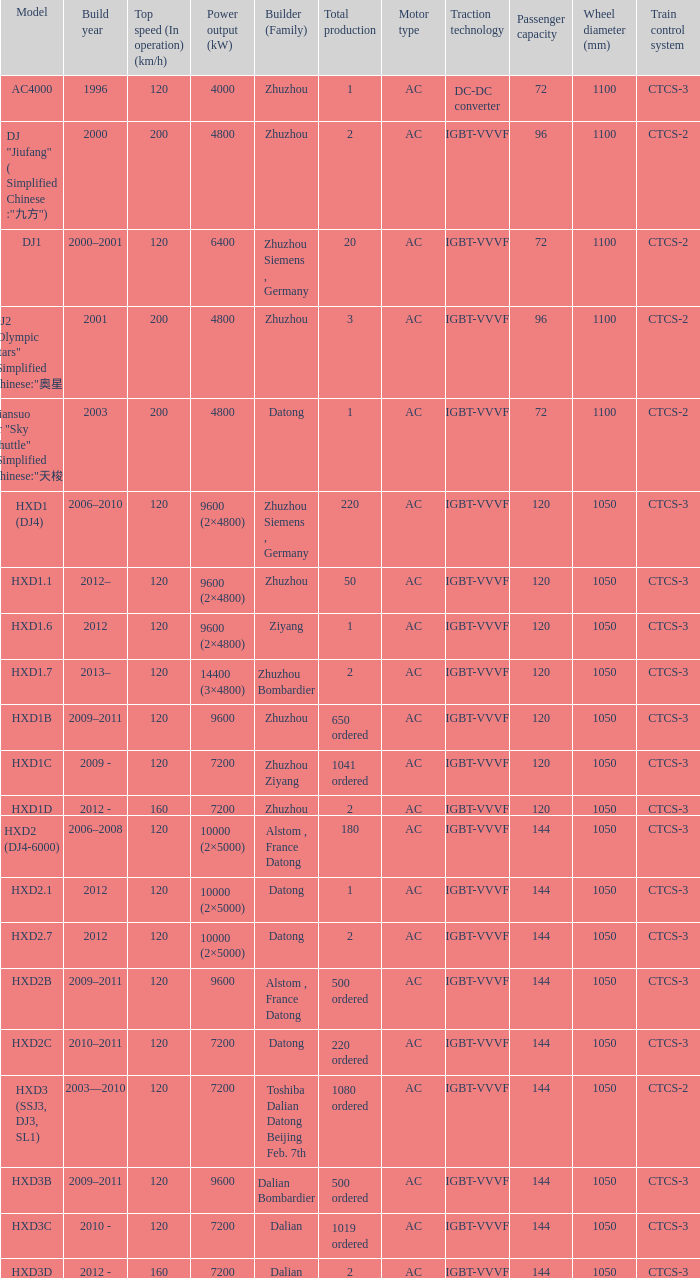What is the power output (kw) of model hxd2b? 9600.0. 